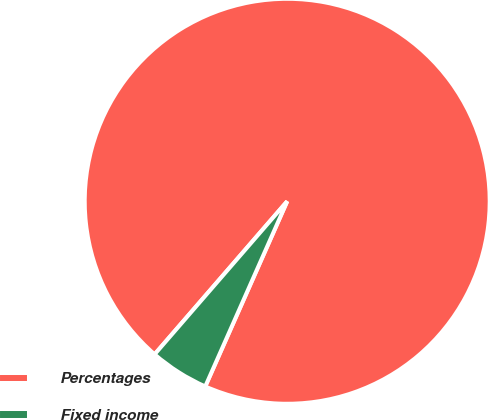Convert chart. <chart><loc_0><loc_0><loc_500><loc_500><pie_chart><fcel>Percentages<fcel>Fixed income<nl><fcel>95.27%<fcel>4.73%<nl></chart> 